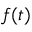<formula> <loc_0><loc_0><loc_500><loc_500>f ( t )</formula> 